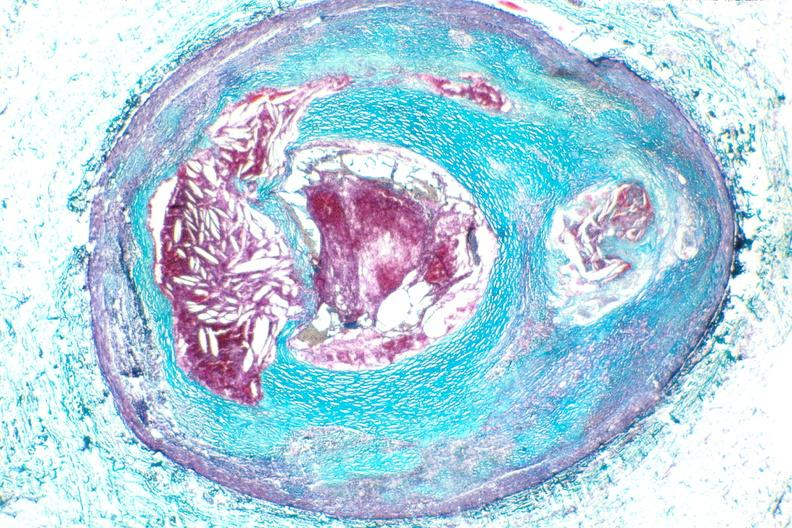s cardiovascular present?
Answer the question using a single word or phrase. Yes 